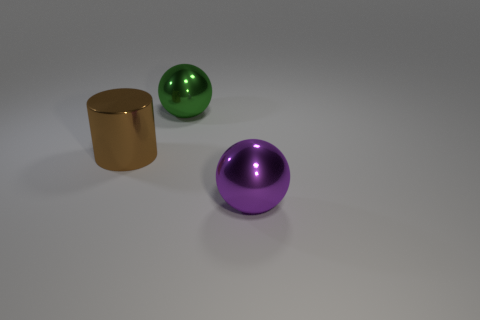Add 2 big brown things. How many objects exist? 5 Subtract all spheres. How many objects are left? 1 Subtract 0 gray cylinders. How many objects are left? 3 Subtract all large metallic things. Subtract all green rubber things. How many objects are left? 0 Add 3 spheres. How many spheres are left? 5 Add 1 small blue matte balls. How many small blue matte balls exist? 1 